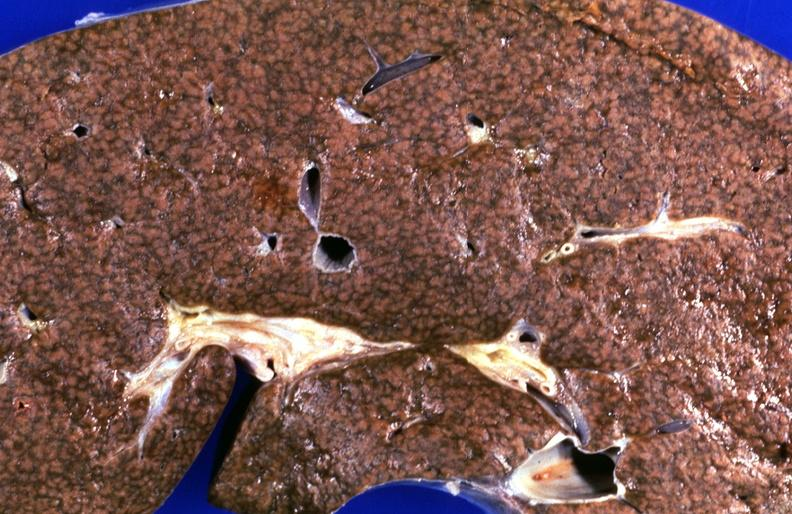s digital infarcts bacterial endocarditis present?
Answer the question using a single word or phrase. No 